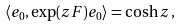Convert formula to latex. <formula><loc_0><loc_0><loc_500><loc_500>\langle e _ { 0 } , \exp ( z F ) e _ { 0 } \rangle = \cosh z \, ,</formula> 